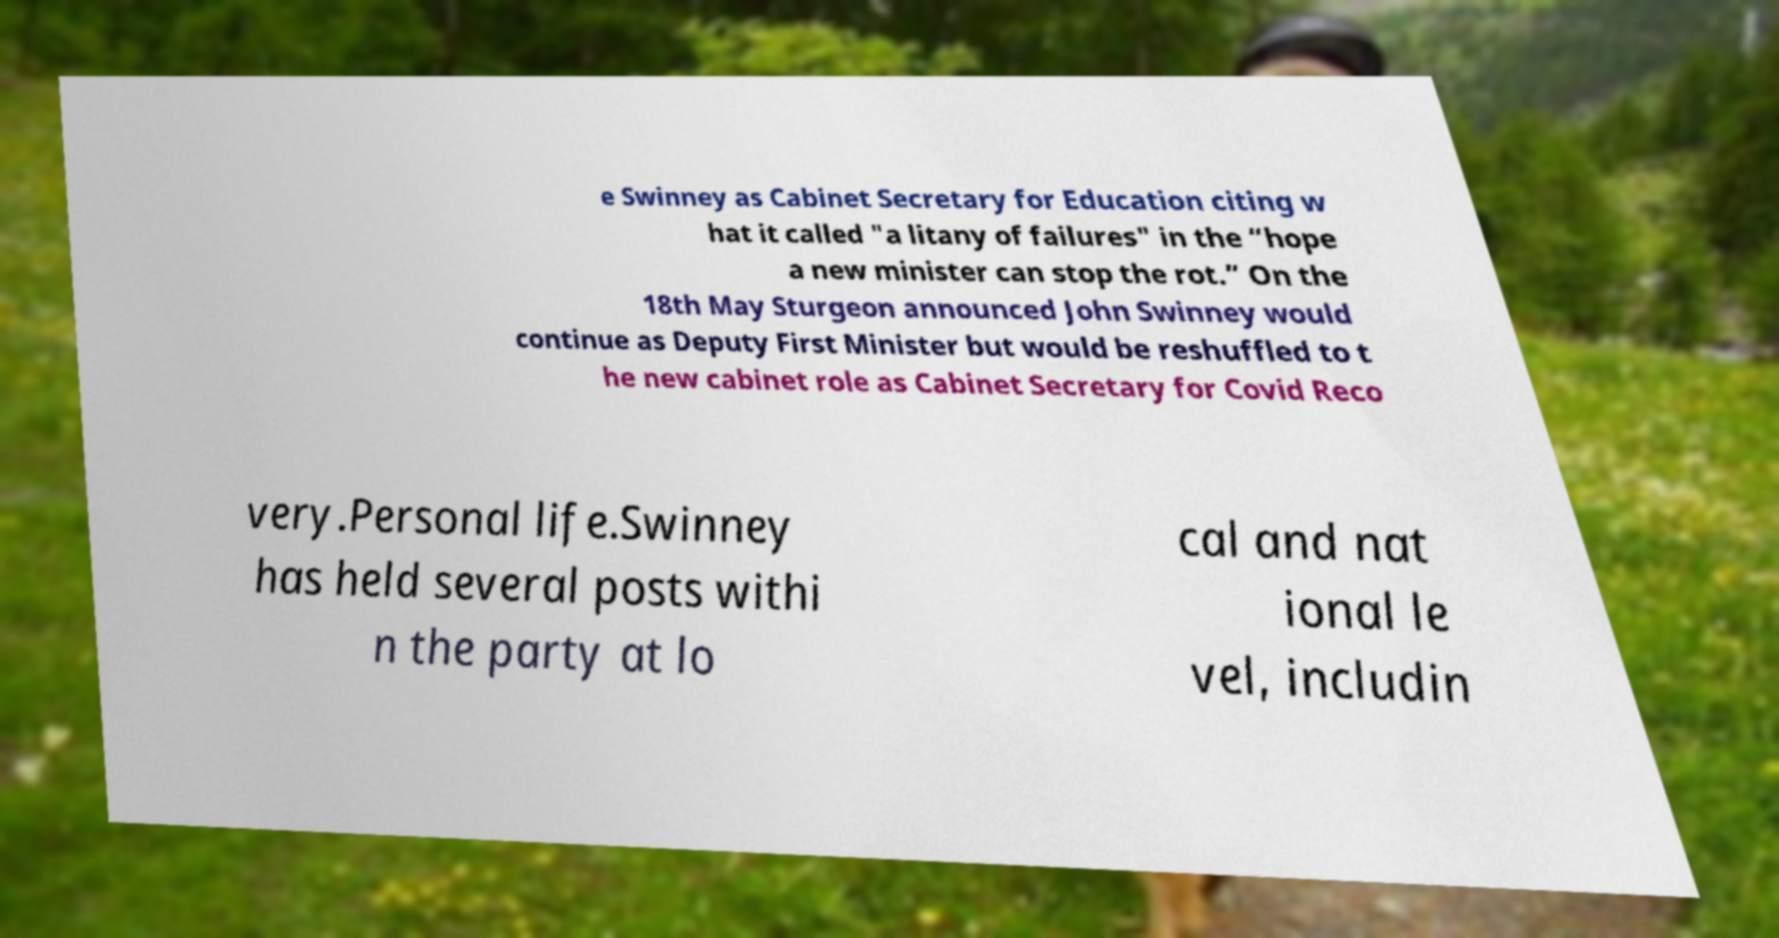I need the written content from this picture converted into text. Can you do that? e Swinney as Cabinet Secretary for Education citing w hat it called "a litany of failures" in the “hope a new minister can stop the rot.” On the 18th May Sturgeon announced John Swinney would continue as Deputy First Minister but would be reshuffled to t he new cabinet role as Cabinet Secretary for Covid Reco very.Personal life.Swinney has held several posts withi n the party at lo cal and nat ional le vel, includin 